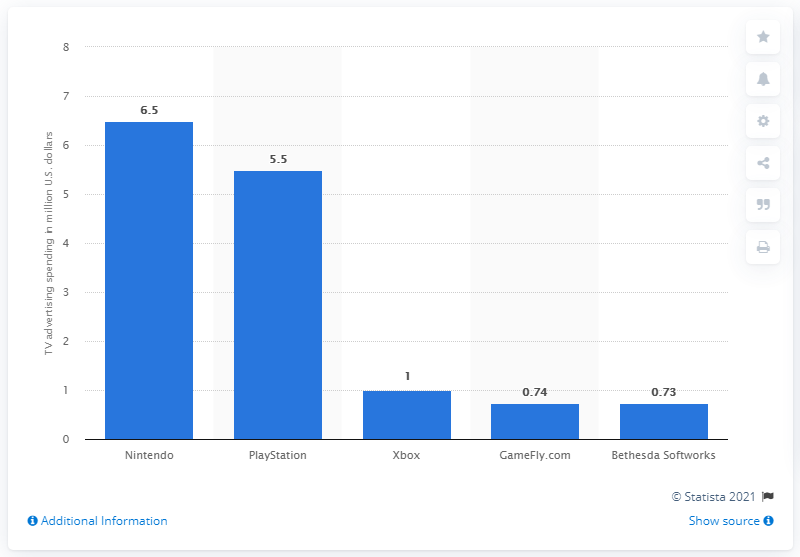Indicate a few pertinent items in this graphic. In April 2020, Nintendo, a leading gaming company, spent approximately 6.5 million dollars on TV advertising. 